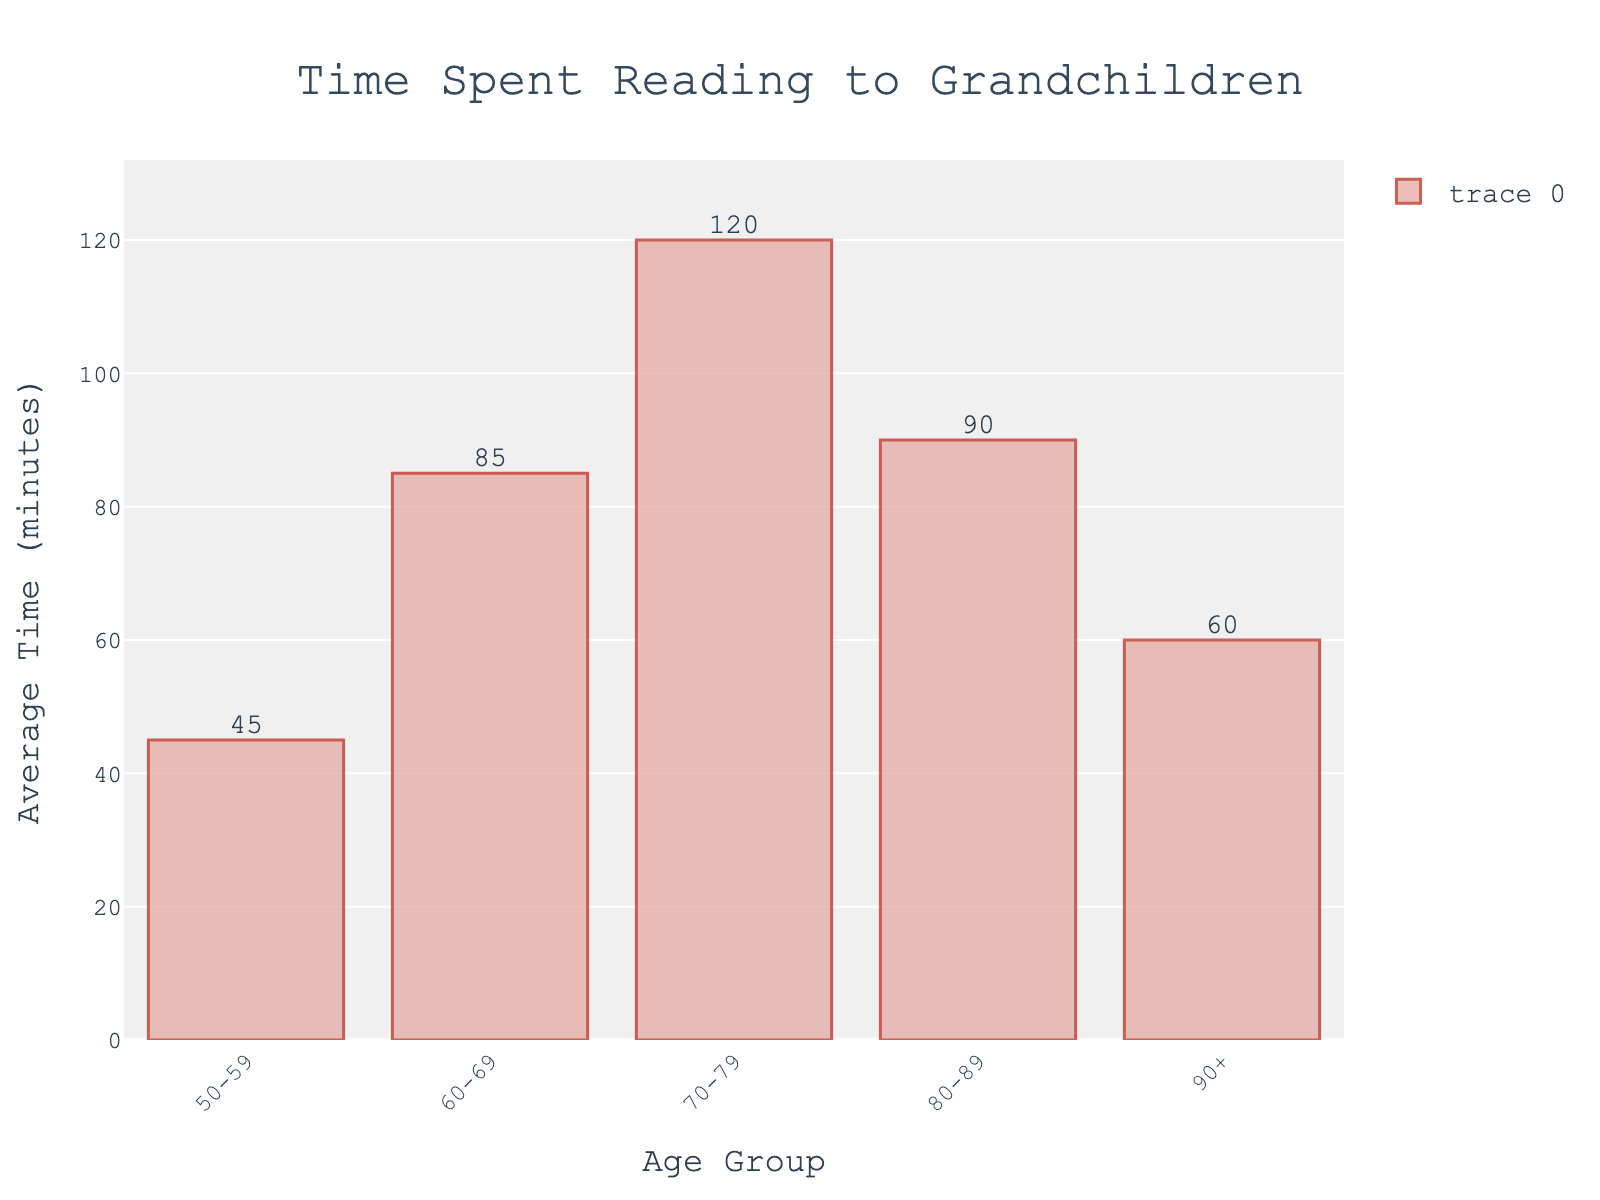Which age group spends the most time reading to grandchildren? Look at the figure and identify the bar that extends the farthest up the y-axis. The age group 70-79 has the tallest bar, indicating it spends the most time reading to grandchildren.
Answer: 70-79 Which age group spends the least time reading to grandchildren? Look at the figure and identify the shortest bar. The age group 50-59 has the shortest bar, indicating it spends the least time reading to grandchildren.
Answer: 50-59 How much more time does the 70-79 age group spend compared to the 50-59 age group? Subtract the value for the 50-59 age group (45 minutes) from the value for the 70-79 age group (120 minutes). The difference is 120 - 45 = 75 minutes.
Answer: 75 minutes Which age group averages 90 minutes of reading to grandchildren per week? Look at the figure and find the bar that reaches 90 on the y-axis. The age group 80-89 has a bar reaching 90 minutes.
Answer: 80-89 Is the average time spent reading higher for the 90+ age group compared to the 50-59 age group? Compare the heights of the bars for the 90+ (60 minutes) and 50-59 (45 minutes) age groups. The 90+ age group spends 15 minutes more.
Answer: Yes What is the combined average time spent reading for the 60-69 and 90+ age groups? Add the values for the 60-69 (85 minutes) and 90+ (60 minutes) age groups. The combined total is 85 + 60 = 145 minutes.
Answer: 145 minutes Which two age groups have the closest average time spent reading to grandchildren? Analyze the figure to find bars with heights closest to each other. The 80-89 (90 minutes) and 90+ (60 minutes) age groups differ by 30 minutes, which is the smallest difference.
Answer: 80-89 and 90+ What is the average time spent reading to grandchildren for all shown age groups combined? Add all the values and divide by the number of age groups: (45 + 85 + 120 + 90 + 60) / 5. The sum is 400, so the average is 400 / 5 = 80 minutes.
Answer: 80 minutes Do more age groups spend above or below the average reading time of the 70-79 age group? Compare each age group's time to the 70-79 group's average (120 minutes). Only the 70-79 group is above its own average.
Answer: Below 